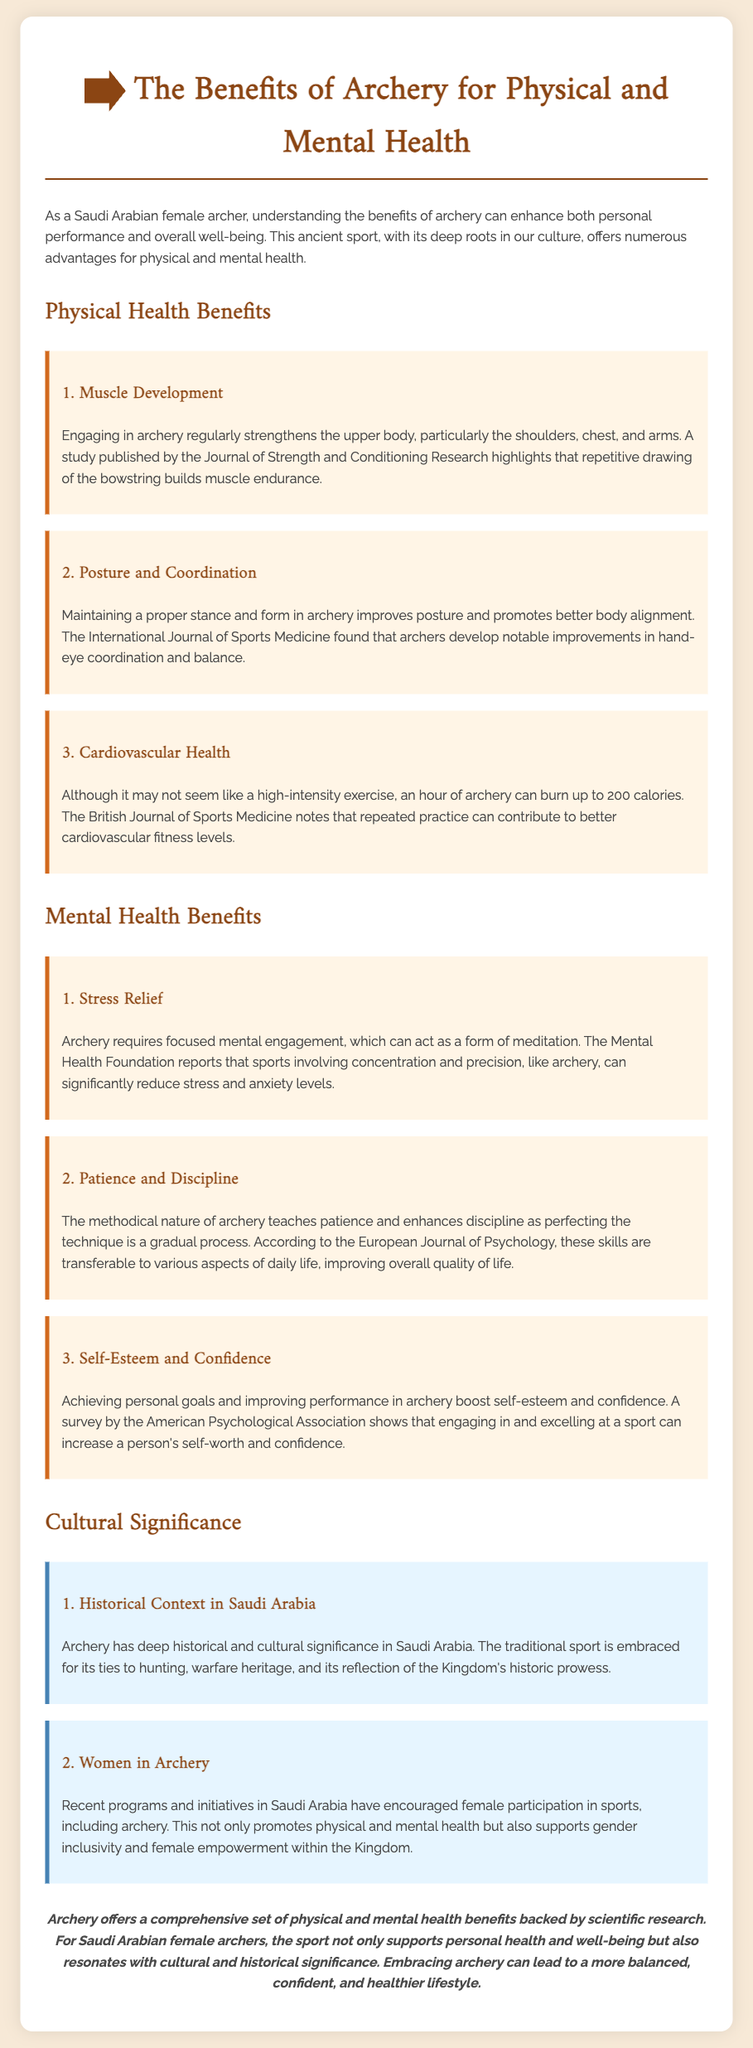what are the physical health benefits of archery? The document lists three physical health benefits: muscle development, posture and coordination, and cardiovascular health.
Answer: muscle development, posture and coordination, cardiovascular health which journal published a study on muscle endurance in archery? The document mentions the Journal of Strength and Conditioning Research as the source for the study on muscle endurance.
Answer: Journal of Strength and Conditioning Research how can archery contribute to stress relief? According to the document, archery requires focused mental engagement, which can act as a form of meditation, helping to reduce stress.
Answer: focused mental engagement which cultural significance is highlighted in relation to Saudi Arabia? The document stresses the historical context of archery in Saudi Arabia, including its ties to hunting and warfare heritage.
Answer: historical context in Saudi Arabia what does the European Journal of Psychology say about archery? The European Journal of Psychology is referenced in relation to how archery teaches patience and enhances discipline.
Answer: teaches patience and enhances discipline how many calories can be burned in an hour of archery? The document states that an hour of archery can burn up to 200 calories.
Answer: 200 calories what is the conclusion drawn about the benefits of archery? The conclusion emphasizes that archery offers a comprehensive set of physical and mental health benefits supported by scientific research.
Answer: comprehensive set of physical and mental health benefits what impact does participating in archery have on self-esteem? Engaging in archery reportedly boosts self-esteem and confidence, as detailed in a survey by the American Psychological Association.
Answer: boosts self-esteem and confidence 